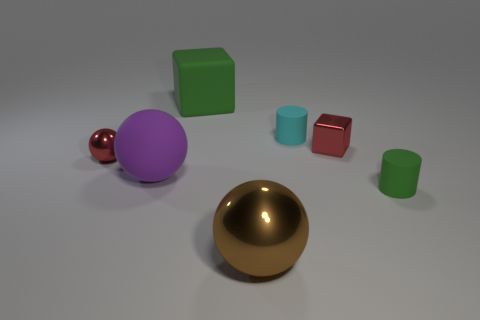Add 1 yellow objects. How many objects exist? 8 Subtract all blocks. How many objects are left? 5 Add 7 big rubber spheres. How many big rubber spheres exist? 8 Subtract 0 gray cylinders. How many objects are left? 7 Subtract all large brown things. Subtract all blue matte things. How many objects are left? 6 Add 6 green blocks. How many green blocks are left? 7 